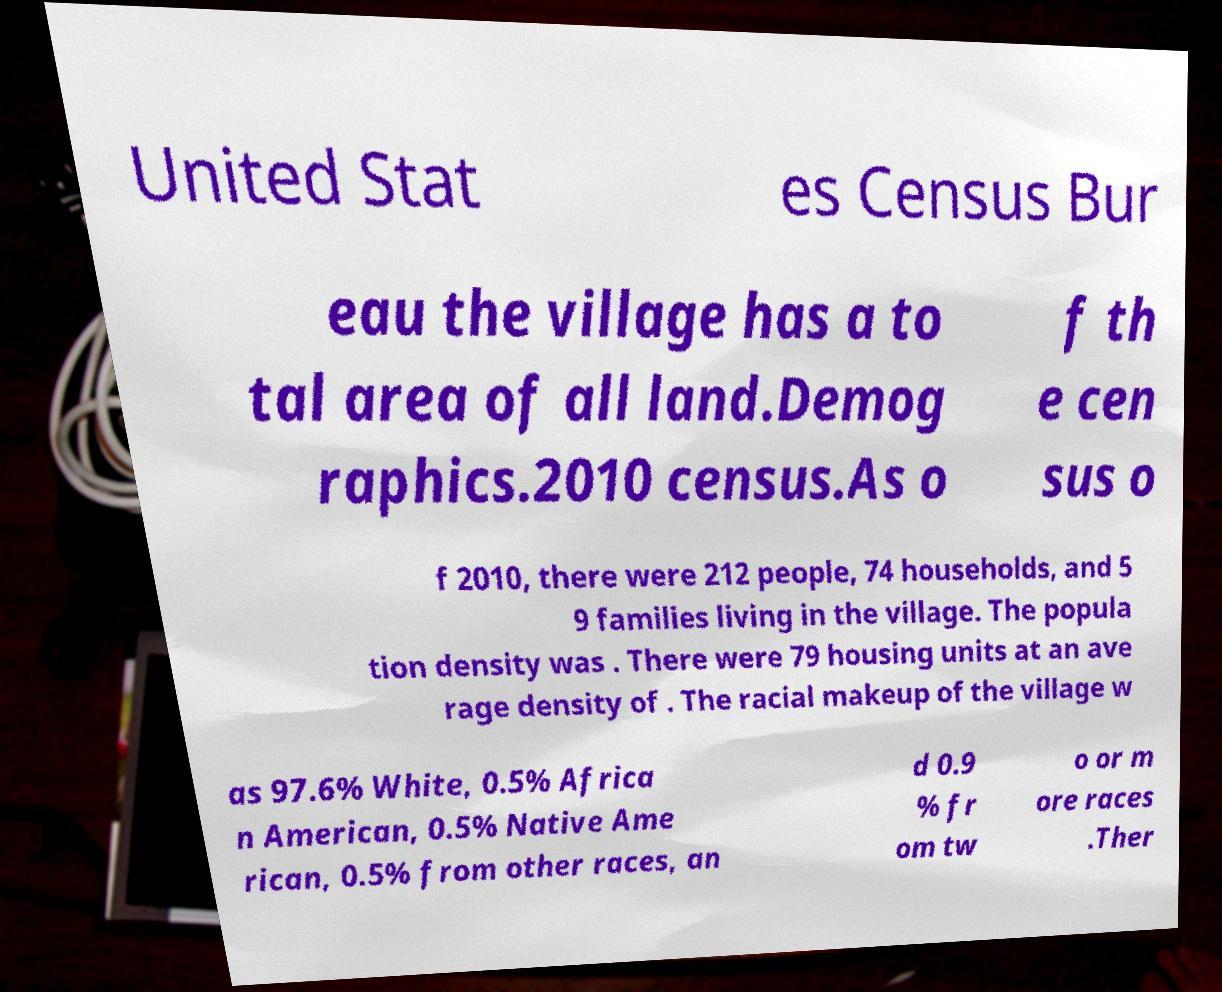There's text embedded in this image that I need extracted. Can you transcribe it verbatim? United Stat es Census Bur eau the village has a to tal area of all land.Demog raphics.2010 census.As o f th e cen sus o f 2010, there were 212 people, 74 households, and 5 9 families living in the village. The popula tion density was . There were 79 housing units at an ave rage density of . The racial makeup of the village w as 97.6% White, 0.5% Africa n American, 0.5% Native Ame rican, 0.5% from other races, an d 0.9 % fr om tw o or m ore races .Ther 